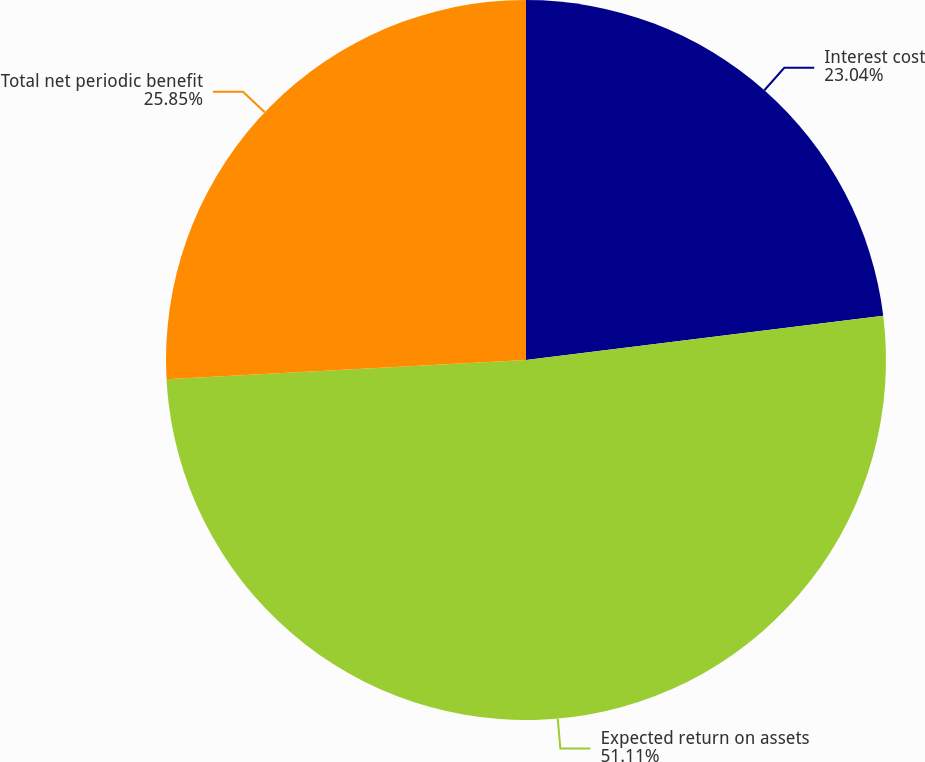Convert chart. <chart><loc_0><loc_0><loc_500><loc_500><pie_chart><fcel>Interest cost<fcel>Expected return on assets<fcel>Total net periodic benefit<nl><fcel>23.04%<fcel>51.12%<fcel>25.85%<nl></chart> 